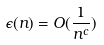Convert formula to latex. <formula><loc_0><loc_0><loc_500><loc_500>\epsilon ( n ) = O ( \frac { 1 } { n ^ { c } } )</formula> 